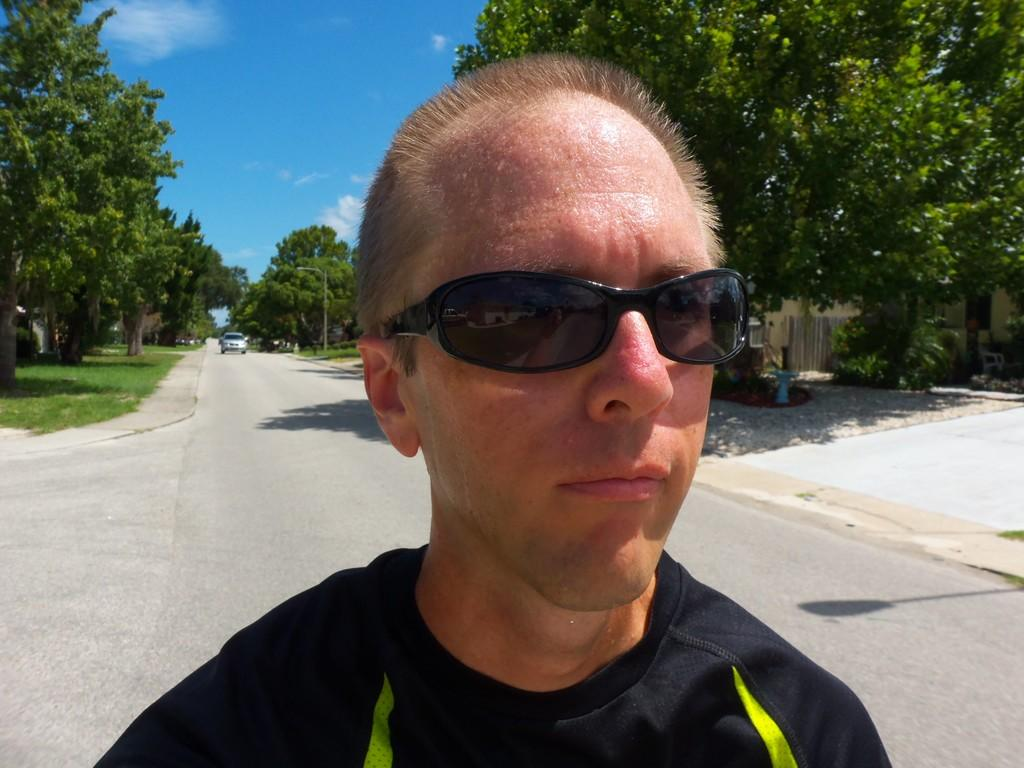What is the main subject of the image? There is a person in the image. What is the person wearing on their upper body? The person is wearing a black shirt. What type of protective eyewear is the person wearing? The person is wearing goggles. What can be seen in the background of the image? There is a car on the road and trees in the background of the image. What is visible at the top of the image? The sky is visible at the top of the image. What type of boot is the person wearing in the image? There is no boot visible in the image; the person is wearing goggles and a black shirt. What holiday is being celebrated in the image? There is no indication of a holiday being celebrated in the image. 